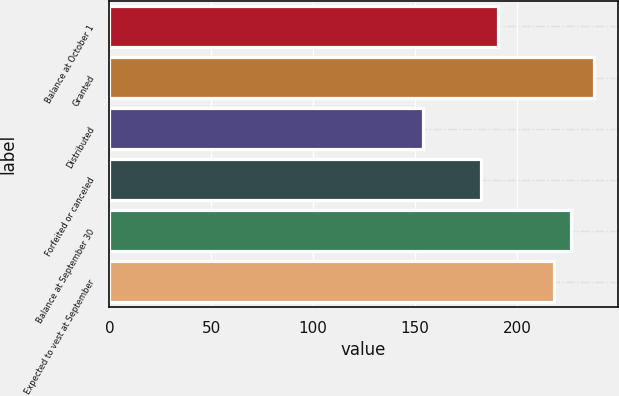Convert chart to OTSL. <chart><loc_0><loc_0><loc_500><loc_500><bar_chart><fcel>Balance at October 1<fcel>Granted<fcel>Distributed<fcel>Forfeited or canceled<fcel>Balance at September 30<fcel>Expected to vest at September<nl><fcel>190.88<fcel>237.55<fcel>153.73<fcel>182.5<fcel>226.44<fcel>218.06<nl></chart> 